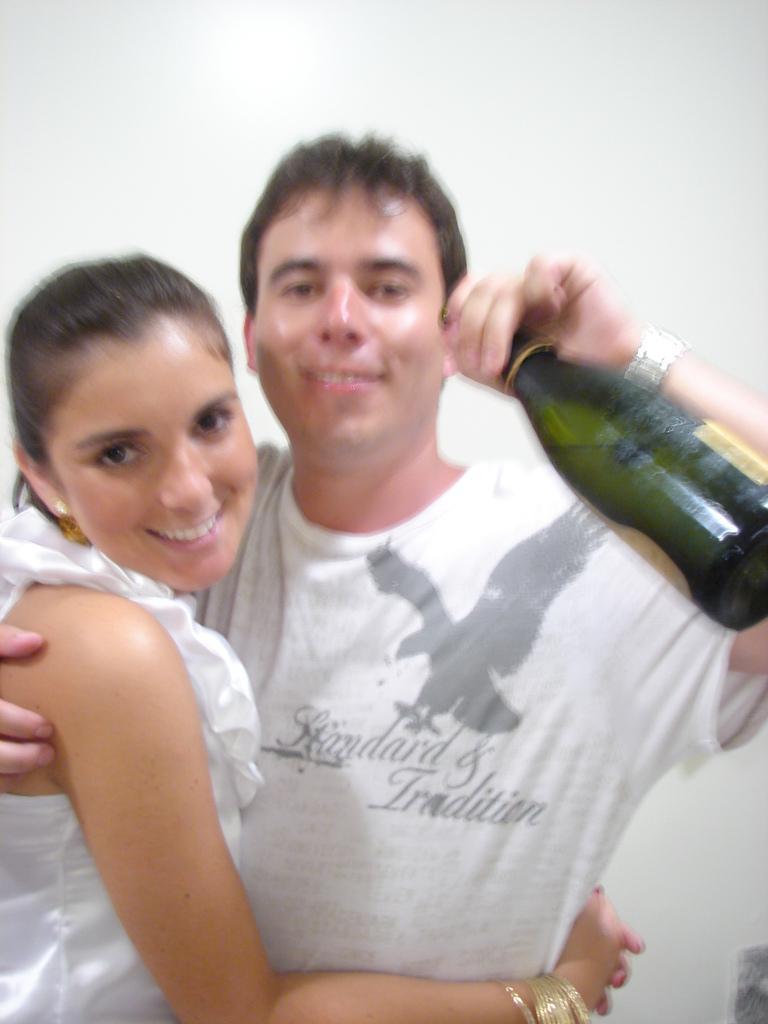Please provide a concise description of this image. This image is clicked in a room. There are two persons in this image. The man is wearing white t-shirt and holding a beer in his hand. The woman is wearing white dress and laughing. 